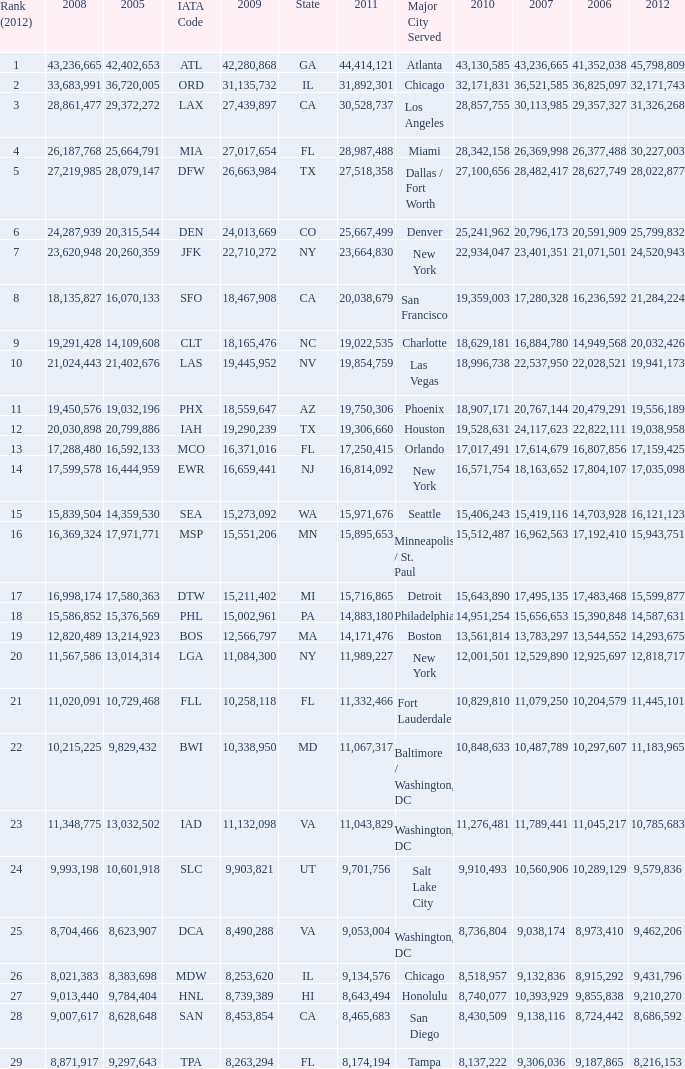For the IATA code of lax with 2009 less than 31,135,732 and 2011 less than 8,174,194, what is the sum of 2012? 0.0. Give me the full table as a dictionary. {'header': ['Rank (2012)', '2008', '2005', 'IATA Code', '2009', 'State', '2011', 'Major City Served', '2010', '2007', '2006', '2012'], 'rows': [['1', '43,236,665', '42,402,653', 'ATL', '42,280,868', 'GA', '44,414,121', 'Atlanta', '43,130,585', '43,236,665', '41,352,038', '45,798,809'], ['2', '33,683,991', '36,720,005', 'ORD', '31,135,732', 'IL', '31,892,301', 'Chicago', '32,171,831', '36,521,585', '36,825,097', '32,171,743'], ['3', '28,861,477', '29,372,272', 'LAX', '27,439,897', 'CA', '30,528,737', 'Los Angeles', '28,857,755', '30,113,985', '29,357,327', '31,326,268'], ['4', '26,187,768', '25,664,791', 'MIA', '27,017,654', 'FL', '28,987,488', 'Miami', '28,342,158', '26,369,998', '26,377,488', '30,227,003'], ['5', '27,219,985', '28,079,147', 'DFW', '26,663,984', 'TX', '27,518,358', 'Dallas / Fort Worth', '27,100,656', '28,482,417', '28,627,749', '28,022,877'], ['6', '24,287,939', '20,315,544', 'DEN', '24,013,669', 'CO', '25,667,499', 'Denver', '25,241,962', '20,796,173', '20,591,909', '25,799,832'], ['7', '23,620,948', '20,260,359', 'JFK', '22,710,272', 'NY', '23,664,830', 'New York', '22,934,047', '23,401,351', '21,071,501', '24,520,943'], ['8', '18,135,827', '16,070,133', 'SFO', '18,467,908', 'CA', '20,038,679', 'San Francisco', '19,359,003', '17,280,328', '16,236,592', '21,284,224'], ['9', '19,291,428', '14,109,608', 'CLT', '18,165,476', 'NC', '19,022,535', 'Charlotte', '18,629,181', '16,884,780', '14,949,568', '20,032,426'], ['10', '21,024,443', '21,402,676', 'LAS', '19,445,952', 'NV', '19,854,759', 'Las Vegas', '18,996,738', '22,537,950', '22,028,521', '19,941,173'], ['11', '19,450,576', '19,032,196', 'PHX', '18,559,647', 'AZ', '19,750,306', 'Phoenix', '18,907,171', '20,767,144', '20,479,291', '19,556,189'], ['12', '20,030,898', '20,799,886', 'IAH', '19,290,239', 'TX', '19,306,660', 'Houston', '19,528,631', '24,117,623', '22,822,111', '19,038,958'], ['13', '17,288,480', '16,592,133', 'MCO', '16,371,016', 'FL', '17,250,415', 'Orlando', '17,017,491', '17,614,679', '16,807,856', '17,159,425'], ['14', '17,599,578', '16,444,959', 'EWR', '16,659,441', 'NJ', '16,814,092', 'New York', '16,571,754', '18,163,652', '17,804,107', '17,035,098'], ['15', '15,839,504', '14,359,530', 'SEA', '15,273,092', 'WA', '15,971,676', 'Seattle', '15,406,243', '15,419,116', '14,703,928', '16,121,123'], ['16', '16,369,324', '17,971,771', 'MSP', '15,551,206', 'MN', '15,895,653', 'Minneapolis / St. Paul', '15,512,487', '16,962,563', '17,192,410', '15,943,751'], ['17', '16,998,174', '17,580,363', 'DTW', '15,211,402', 'MI', '15,716,865', 'Detroit', '15,643,890', '17,495,135', '17,483,468', '15,599,877'], ['18', '15,586,852', '15,376,569', 'PHL', '15,002,961', 'PA', '14,883,180', 'Philadelphia', '14,951,254', '15,656,653', '15,390,848', '14,587,631'], ['19', '12,820,489', '13,214,923', 'BOS', '12,566,797', 'MA', '14,171,476', 'Boston', '13,561,814', '13,783,297', '13,544,552', '14,293,675'], ['20', '11,567,586', '13,014,314', 'LGA', '11,084,300', 'NY', '11,989,227', 'New York', '12,001,501', '12,529,890', '12,925,697', '12,818,717'], ['21', '11,020,091', '10,729,468', 'FLL', '10,258,118', 'FL', '11,332,466', 'Fort Lauderdale', '10,829,810', '11,079,250', '10,204,579', '11,445,101'], ['22', '10,215,225', '9,829,432', 'BWI', '10,338,950', 'MD', '11,067,317', 'Baltimore / Washington, DC', '10,848,633', '10,487,789', '10,297,607', '11,183,965'], ['23', '11,348,775', '13,032,502', 'IAD', '11,132,098', 'VA', '11,043,829', 'Washington, DC', '11,276,481', '11,789,441', '11,045,217', '10,785,683'], ['24', '9,993,198', '10,601,918', 'SLC', '9,903,821', 'UT', '9,701,756', 'Salt Lake City', '9,910,493', '10,560,906', '10,289,129', '9,579,836'], ['25', '8,704,466', '8,623,907', 'DCA', '8,490,288', 'VA', '9,053,004', 'Washington, DC', '8,736,804', '9,038,174', '8,973,410', '9,462,206'], ['26', '8,021,383', '8,383,698', 'MDW', '8,253,620', 'IL', '9,134,576', 'Chicago', '8,518,957', '9,132,836', '8,915,292', '9,431,796'], ['27', '9,013,440', '9,784,404', 'HNL', '8,739,389', 'HI', '8,643,494', 'Honolulu', '8,740,077', '10,393,929', '9,855,838', '9,210,270'], ['28', '9,007,617', '8,628,648', 'SAN', '8,453,854', 'CA', '8,465,683', 'San Diego', '8,430,509', '9,138,116', '8,724,442', '8,686,592'], ['29', '8,871,917', '9,297,643', 'TPA', '8,263,294', 'FL', '8,174,194', 'Tampa', '8,137,222', '9,306,036', '9,187,865', '8,216,153']]} 